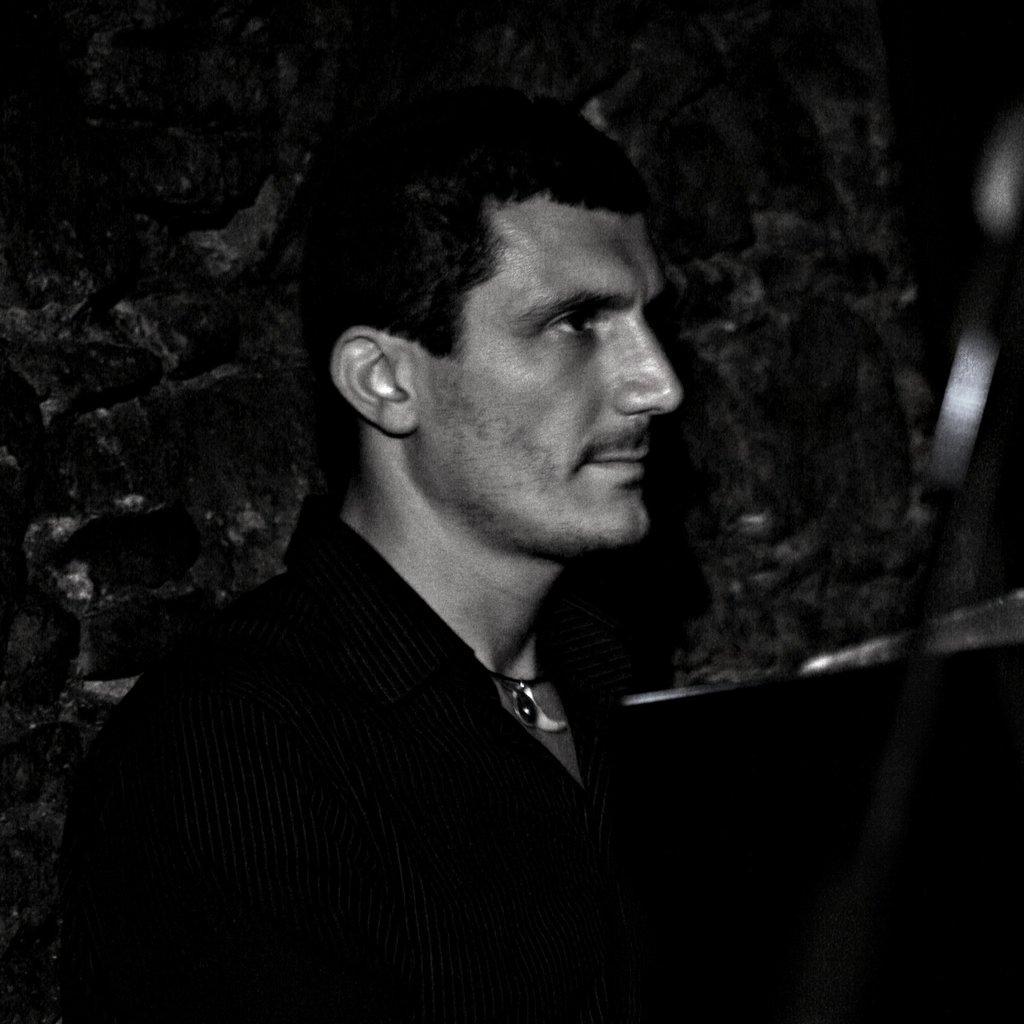How would you summarize this image in a sentence or two? It is the black and white image of a man. In the background there is a wall. 